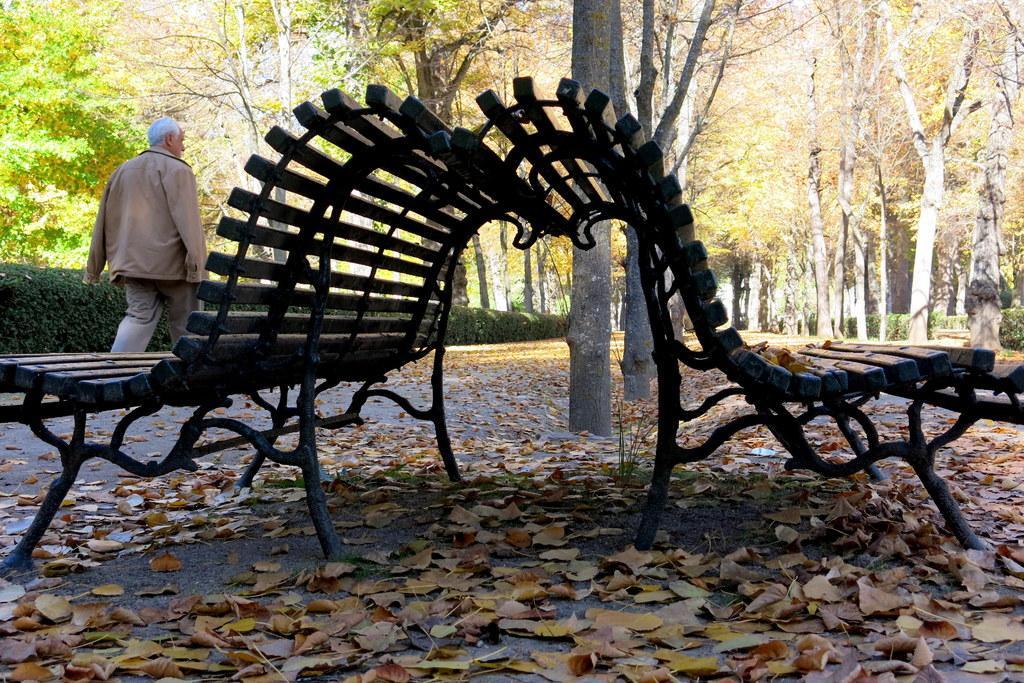In one or two sentences, can you explain what this image depicts? In this image i can see 2 benches and a person walking. In the background i can see trees and few other benches. 